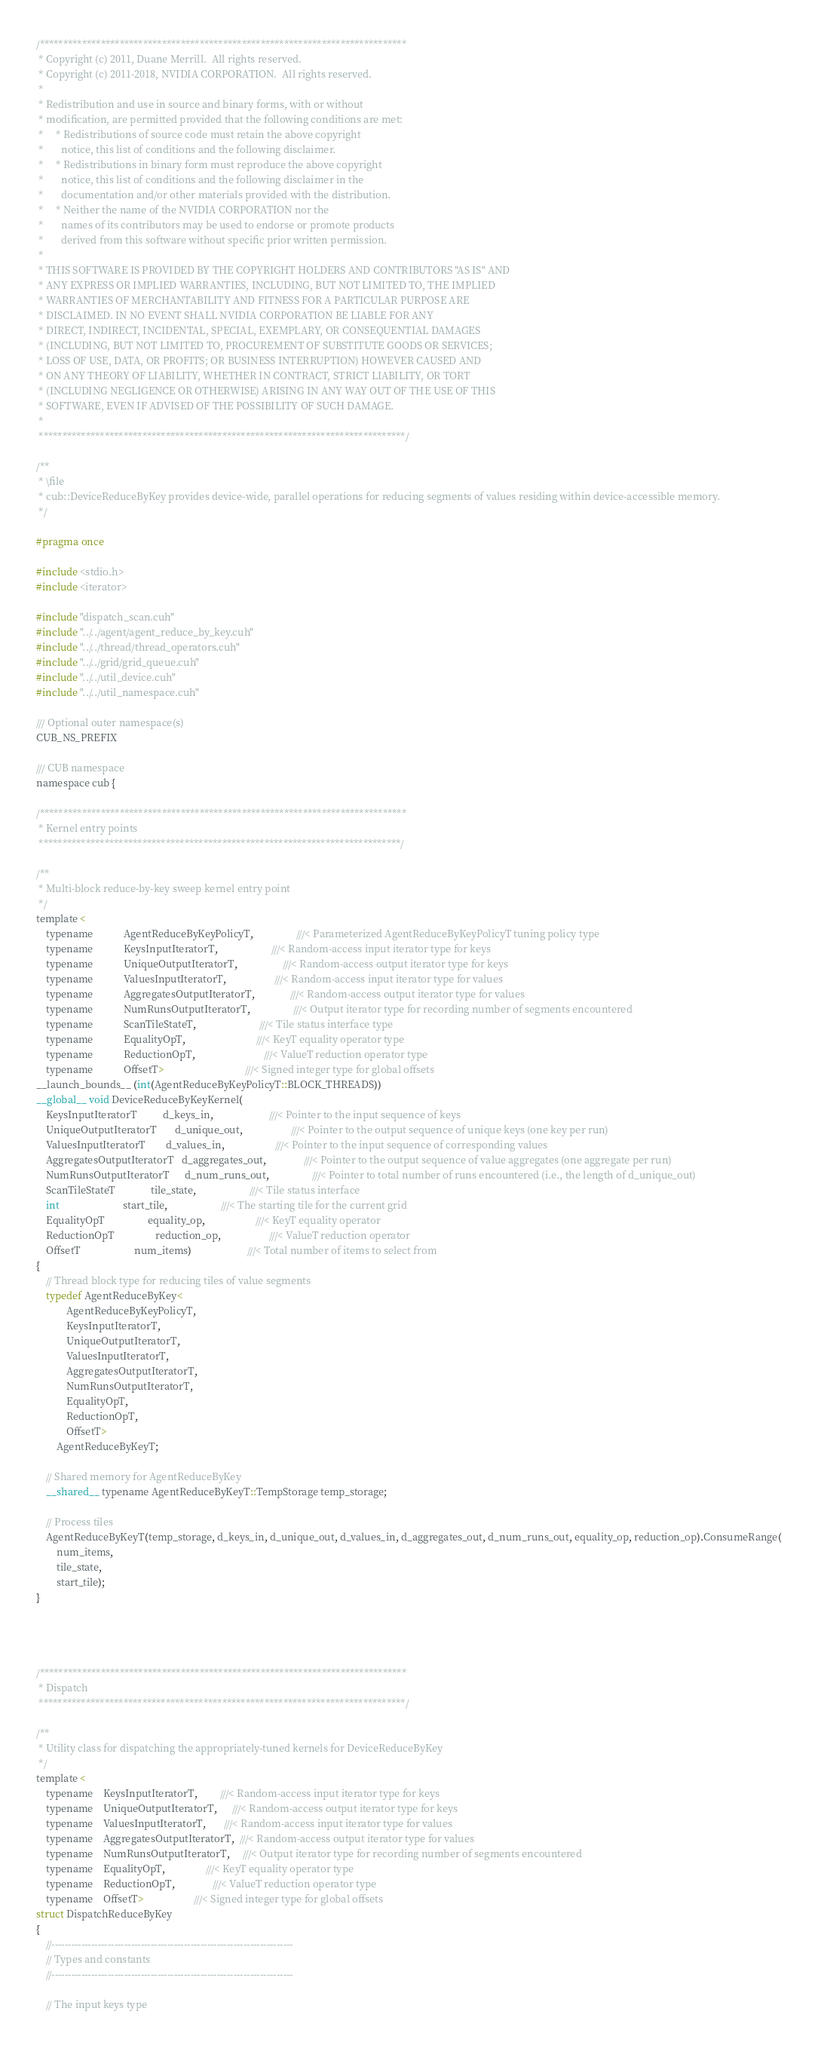Convert code to text. <code><loc_0><loc_0><loc_500><loc_500><_Cuda_>
/******************************************************************************
 * Copyright (c) 2011, Duane Merrill.  All rights reserved.
 * Copyright (c) 2011-2018, NVIDIA CORPORATION.  All rights reserved.
 *
 * Redistribution and use in source and binary forms, with or without
 * modification, are permitted provided that the following conditions are met:
 *     * Redistributions of source code must retain the above copyright
 *       notice, this list of conditions and the following disclaimer.
 *     * Redistributions in binary form must reproduce the above copyright
 *       notice, this list of conditions and the following disclaimer in the
 *       documentation and/or other materials provided with the distribution.
 *     * Neither the name of the NVIDIA CORPORATION nor the
 *       names of its contributors may be used to endorse or promote products
 *       derived from this software without specific prior written permission.
 *
 * THIS SOFTWARE IS PROVIDED BY THE COPYRIGHT HOLDERS AND CONTRIBUTORS "AS IS" AND
 * ANY EXPRESS OR IMPLIED WARRANTIES, INCLUDING, BUT NOT LIMITED TO, THE IMPLIED
 * WARRANTIES OF MERCHANTABILITY AND FITNESS FOR A PARTICULAR PURPOSE ARE
 * DISCLAIMED. IN NO EVENT SHALL NVIDIA CORPORATION BE LIABLE FOR ANY
 * DIRECT, INDIRECT, INCIDENTAL, SPECIAL, EXEMPLARY, OR CONSEQUENTIAL DAMAGES
 * (INCLUDING, BUT NOT LIMITED TO, PROCUREMENT OF SUBSTITUTE GOODS OR SERVICES;
 * LOSS OF USE, DATA, OR PROFITS; OR BUSINESS INTERRUPTION) HOWEVER CAUSED AND
 * ON ANY THEORY OF LIABILITY, WHETHER IN CONTRACT, STRICT LIABILITY, OR TORT
 * (INCLUDING NEGLIGENCE OR OTHERWISE) ARISING IN ANY WAY OUT OF THE USE OF THIS
 * SOFTWARE, EVEN IF ADVISED OF THE POSSIBILITY OF SUCH DAMAGE.
 *
 ******************************************************************************/

/**
 * \file
 * cub::DeviceReduceByKey provides device-wide, parallel operations for reducing segments of values residing within device-accessible memory.
 */

#pragma once

#include <stdio.h>
#include <iterator>

#include "dispatch_scan.cuh"
#include "../../agent/agent_reduce_by_key.cuh"
#include "../../thread/thread_operators.cuh"
#include "../../grid/grid_queue.cuh"
#include "../../util_device.cuh"
#include "../../util_namespace.cuh"

/// Optional outer namespace(s)
CUB_NS_PREFIX

/// CUB namespace
namespace cub {

/******************************************************************************
 * Kernel entry points
 *****************************************************************************/

/**
 * Multi-block reduce-by-key sweep kernel entry point
 */
template <
    typename            AgentReduceByKeyPolicyT,                 ///< Parameterized AgentReduceByKeyPolicyT tuning policy type
    typename            KeysInputIteratorT,                     ///< Random-access input iterator type for keys
    typename            UniqueOutputIteratorT,                  ///< Random-access output iterator type for keys
    typename            ValuesInputIteratorT,                   ///< Random-access input iterator type for values
    typename            AggregatesOutputIteratorT,              ///< Random-access output iterator type for values
    typename            NumRunsOutputIteratorT,                 ///< Output iterator type for recording number of segments encountered
    typename            ScanTileStateT,                         ///< Tile status interface type
    typename            EqualityOpT,                            ///< KeyT equality operator type
    typename            ReductionOpT,                           ///< ValueT reduction operator type
    typename            OffsetT>                                ///< Signed integer type for global offsets
__launch_bounds__ (int(AgentReduceByKeyPolicyT::BLOCK_THREADS))
__global__ void DeviceReduceByKeyKernel(
    KeysInputIteratorT          d_keys_in,                      ///< Pointer to the input sequence of keys
    UniqueOutputIteratorT       d_unique_out,                   ///< Pointer to the output sequence of unique keys (one key per run)
    ValuesInputIteratorT        d_values_in,                    ///< Pointer to the input sequence of corresponding values
    AggregatesOutputIteratorT   d_aggregates_out,               ///< Pointer to the output sequence of value aggregates (one aggregate per run)
    NumRunsOutputIteratorT      d_num_runs_out,                 ///< Pointer to total number of runs encountered (i.e., the length of d_unique_out)
    ScanTileStateT              tile_state,                     ///< Tile status interface
    int                         start_tile,                     ///< The starting tile for the current grid
    EqualityOpT                 equality_op,                    ///< KeyT equality operator
    ReductionOpT                reduction_op,                   ///< ValueT reduction operator
    OffsetT                     num_items)                      ///< Total number of items to select from
{
    // Thread block type for reducing tiles of value segments
    typedef AgentReduceByKey<
            AgentReduceByKeyPolicyT,
            KeysInputIteratorT,
            UniqueOutputIteratorT,
            ValuesInputIteratorT,
            AggregatesOutputIteratorT,
            NumRunsOutputIteratorT,
            EqualityOpT,
            ReductionOpT,
            OffsetT>
        AgentReduceByKeyT;

    // Shared memory for AgentReduceByKey
    __shared__ typename AgentReduceByKeyT::TempStorage temp_storage;

    // Process tiles
    AgentReduceByKeyT(temp_storage, d_keys_in, d_unique_out, d_values_in, d_aggregates_out, d_num_runs_out, equality_op, reduction_op).ConsumeRange(
        num_items,
        tile_state,
        start_tile);
}




/******************************************************************************
 * Dispatch
 ******************************************************************************/

/**
 * Utility class for dispatching the appropriately-tuned kernels for DeviceReduceByKey
 */
template <
    typename    KeysInputIteratorT,         ///< Random-access input iterator type for keys
    typename    UniqueOutputIteratorT,      ///< Random-access output iterator type for keys
    typename    ValuesInputIteratorT,       ///< Random-access input iterator type for values
    typename    AggregatesOutputIteratorT,  ///< Random-access output iterator type for values
    typename    NumRunsOutputIteratorT,     ///< Output iterator type for recording number of segments encountered
    typename    EqualityOpT,                ///< KeyT equality operator type
    typename    ReductionOpT,               ///< ValueT reduction operator type
    typename    OffsetT>                    ///< Signed integer type for global offsets
struct DispatchReduceByKey
{
    //-------------------------------------------------------------------------
    // Types and constants
    //-------------------------------------------------------------------------

    // The input keys type</code> 